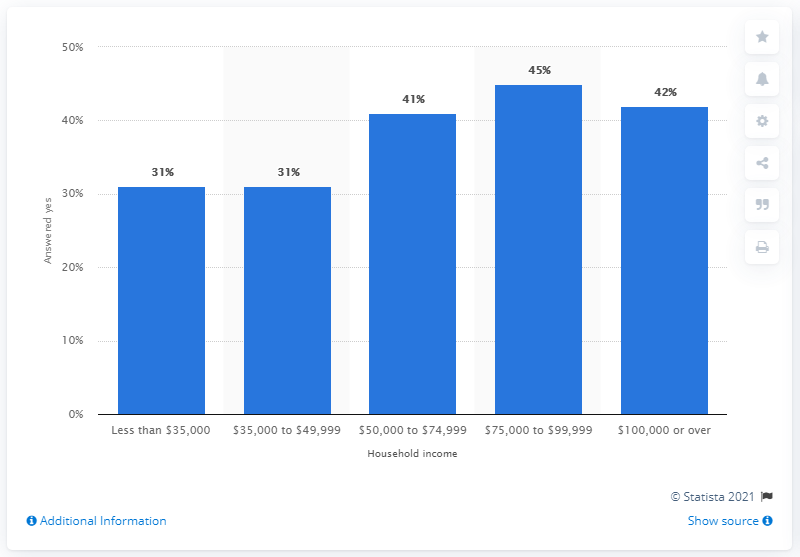Which income bracket shows the highest percentage of Major League Baseball followers? The income bracket showing the highest percentage of Major League Baseball followers is those earning between $75,000 to $99,999, with 45% indicating they follow the sport.  Can you describe the overall trend in interest in Major League Baseball based on household income? Certainly! The bar chart suggests a general upward trend in the interest in Major League Baseball with increasing household income. Starting from a 31% interest rate for the lowest income bracket, there's a noticeable increase peaking at 45% for the $75,000 to $99,999 bracket, before slightly declining to 42% for those earning $100,000 or over. 